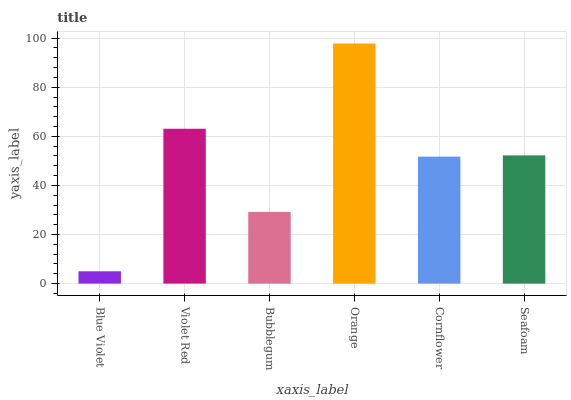Is Blue Violet the minimum?
Answer yes or no. Yes. Is Orange the maximum?
Answer yes or no. Yes. Is Violet Red the minimum?
Answer yes or no. No. Is Violet Red the maximum?
Answer yes or no. No. Is Violet Red greater than Blue Violet?
Answer yes or no. Yes. Is Blue Violet less than Violet Red?
Answer yes or no. Yes. Is Blue Violet greater than Violet Red?
Answer yes or no. No. Is Violet Red less than Blue Violet?
Answer yes or no. No. Is Seafoam the high median?
Answer yes or no. Yes. Is Cornflower the low median?
Answer yes or no. Yes. Is Bubblegum the high median?
Answer yes or no. No. Is Bubblegum the low median?
Answer yes or no. No. 